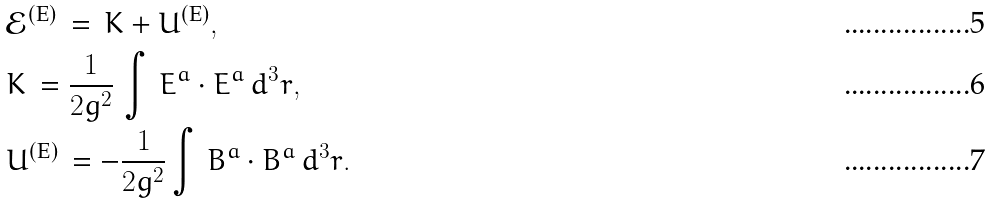Convert formula to latex. <formula><loc_0><loc_0><loc_500><loc_500>& \mathcal { E } ^ { ( \text {E} ) } \, = \, K + U ^ { ( \text {E} ) } , \\ & K \, = \frac { 1 } { 2 g ^ { 2 } } \, \int \, { E ^ { a } } \cdot { E ^ { a } } \, d ^ { 3 } r , \\ & U ^ { ( \text {E} ) } \, = - \frac { 1 } { 2 g ^ { 2 } } \int \, { B ^ { a } } \cdot { B ^ { a } } \, d ^ { 3 } r .</formula> 